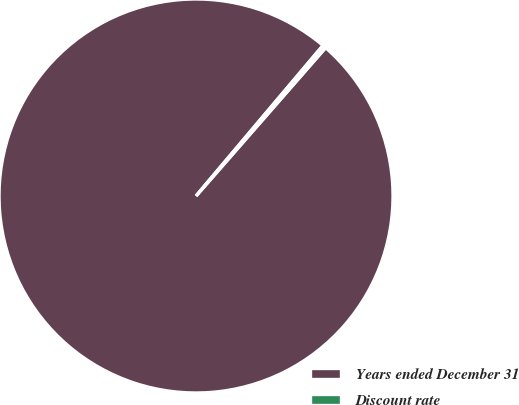Convert chart. <chart><loc_0><loc_0><loc_500><loc_500><pie_chart><fcel>Years ended December 31<fcel>Discount rate<nl><fcel>99.73%<fcel>0.27%<nl></chart> 